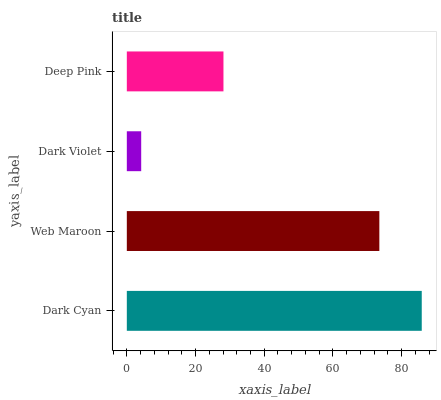Is Dark Violet the minimum?
Answer yes or no. Yes. Is Dark Cyan the maximum?
Answer yes or no. Yes. Is Web Maroon the minimum?
Answer yes or no. No. Is Web Maroon the maximum?
Answer yes or no. No. Is Dark Cyan greater than Web Maroon?
Answer yes or no. Yes. Is Web Maroon less than Dark Cyan?
Answer yes or no. Yes. Is Web Maroon greater than Dark Cyan?
Answer yes or no. No. Is Dark Cyan less than Web Maroon?
Answer yes or no. No. Is Web Maroon the high median?
Answer yes or no. Yes. Is Deep Pink the low median?
Answer yes or no. Yes. Is Dark Cyan the high median?
Answer yes or no. No. Is Web Maroon the low median?
Answer yes or no. No. 